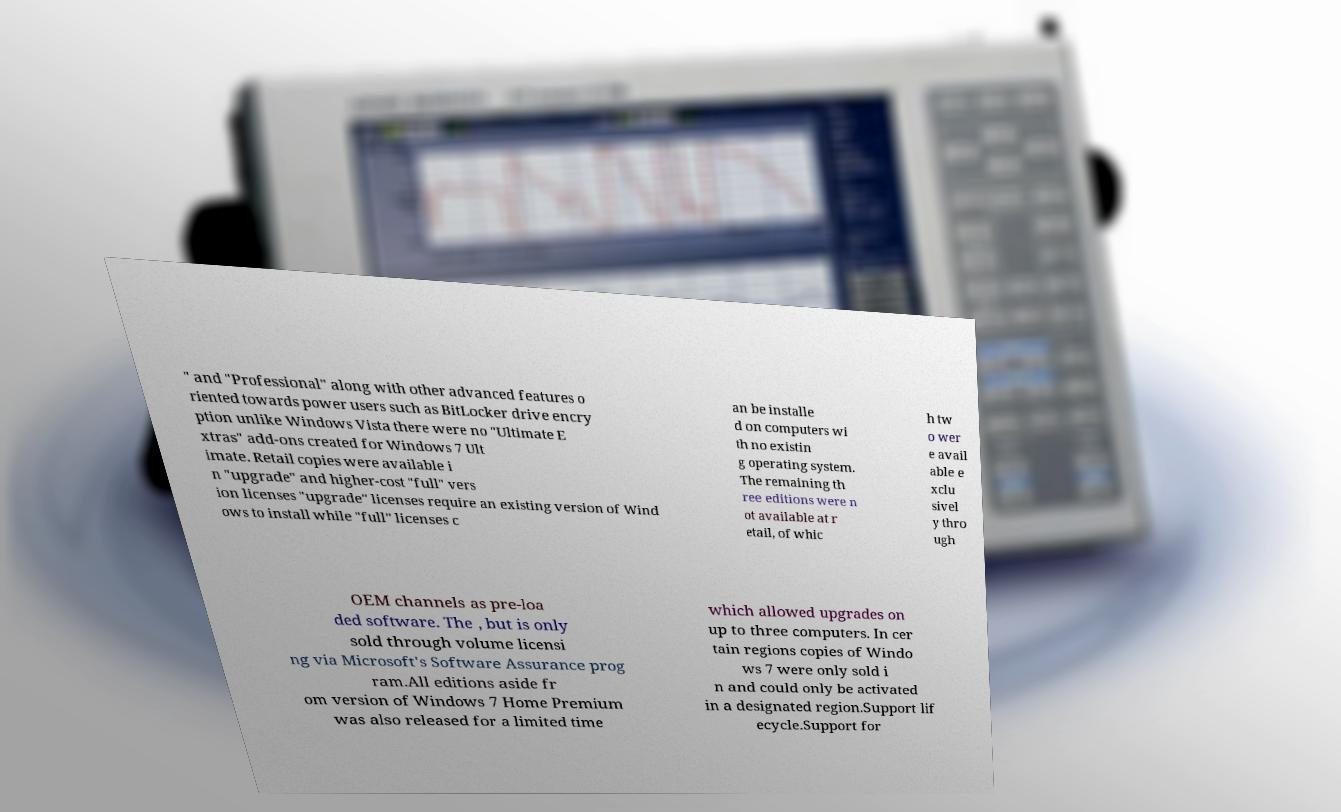Please identify and transcribe the text found in this image. " and "Professional" along with other advanced features o riented towards power users such as BitLocker drive encry ption unlike Windows Vista there were no "Ultimate E xtras" add-ons created for Windows 7 Ult imate. Retail copies were available i n "upgrade" and higher-cost "full" vers ion licenses "upgrade" licenses require an existing version of Wind ows to install while "full" licenses c an be installe d on computers wi th no existin g operating system. The remaining th ree editions were n ot available at r etail, of whic h tw o wer e avail able e xclu sivel y thro ugh OEM channels as pre-loa ded software. The , but is only sold through volume licensi ng via Microsoft's Software Assurance prog ram.All editions aside fr om version of Windows 7 Home Premium was also released for a limited time which allowed upgrades on up to three computers. In cer tain regions copies of Windo ws 7 were only sold i n and could only be activated in a designated region.Support lif ecycle.Support for 